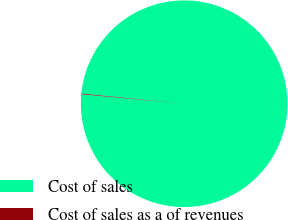Convert chart. <chart><loc_0><loc_0><loc_500><loc_500><pie_chart><fcel>Cost of sales<fcel>Cost of sales as a of revenues<nl><fcel>99.89%<fcel>0.11%<nl></chart> 